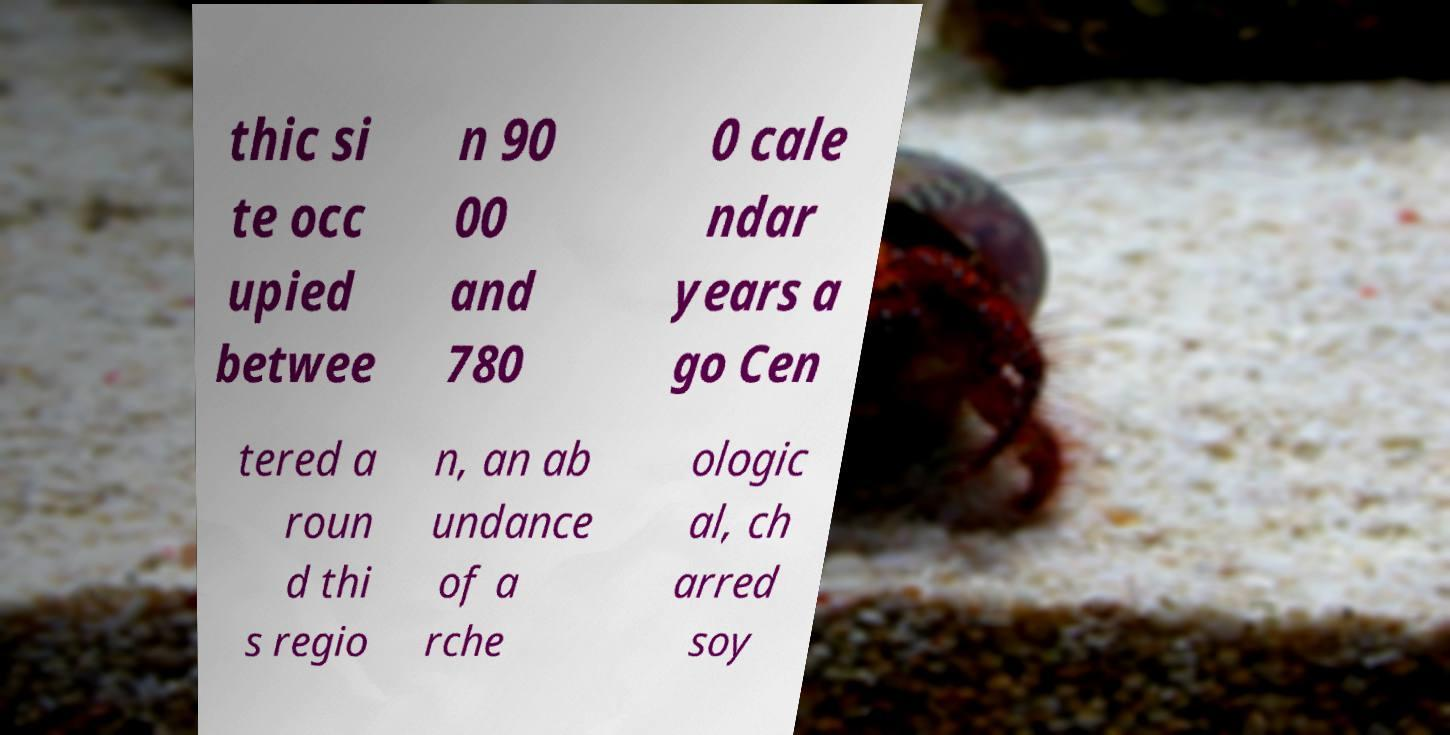Can you read and provide the text displayed in the image?This photo seems to have some interesting text. Can you extract and type it out for me? thic si te occ upied betwee n 90 00 and 780 0 cale ndar years a go Cen tered a roun d thi s regio n, an ab undance of a rche ologic al, ch arred soy 